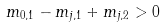Convert formula to latex. <formula><loc_0><loc_0><loc_500><loc_500>m _ { 0 , 1 } - m _ { j , 1 } + m _ { j , 2 } > 0</formula> 